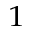Convert formula to latex. <formula><loc_0><loc_0><loc_500><loc_500>^ { 1 }</formula> 